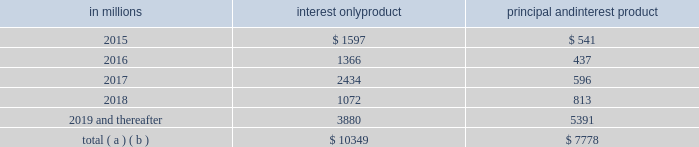On a regular basis our special asset committee closely monitors loans , primarily commercial loans , that are not included in the nonperforming or accruing past due categories and for which we are uncertain about the borrower 2019s ability to comply with existing repayment terms .
These loans totaled $ .2 billion at both december 31 , 2014 and december 31 , 2013 .
Home equity loan portfolio our home equity loan portfolio totaled $ 34.7 billion as of december 31 , 2014 , or 17% ( 17 % ) of the total loan portfolio .
Of that total , $ 20.4 billion , or 59% ( 59 % ) , was outstanding under primarily variable-rate home equity lines of credit and $ 14.3 billion , or 41% ( 41 % ) , consisted of closed-end home equity installment loans .
Approximately 3% ( 3 % ) of the home equity portfolio was on nonperforming status as of december 31 , 2014 .
As of december 31 , 2014 , we are in an originated first lien position for approximately 51% ( 51 % ) of the total portfolio and , where originated as a second lien , we currently hold or service the first lien position for approximately an additional 2% ( 2 % ) of the portfolio .
The remaining 47% ( 47 % ) of the portfolio was secured by second liens where we do not hold the first lien position .
The credit performance of the majority of the home equity portfolio where we are in , hold or service the first lien position , is superior to the portion of the portfolio where we hold the second lien position but do not hold the first lien .
Lien position information is generally based upon original ltv at the time of origination .
However , after origination pnc is not typically notified when a senior lien position that is not held by pnc is satisfied .
Therefore , information about the current lien status of junior lien loans is less readily available in cases where pnc does not also hold the senior lien .
Additionally , pnc is not typically notified when a junior lien position is added after origination of a pnc first lien .
This updated information for both junior and senior liens must be obtained from external sources , and therefore , pnc has contracted with an industry-leading third-party service provider to obtain updated loan , lien and collateral data that is aggregated from public and private sources .
We track borrower performance monthly , including obtaining original ltvs , updated fico scores at least quarterly , updated ltvs semi-annually , and other credit metrics at least quarterly , including the historical performance of any mortgage loans regardless of lien position that we do or do not hold .
This information is used for internal reporting and risk management .
For internal reporting and risk management we also segment the population into pools based on product type ( e.g. , home equity loans , brokered home equity loans , home equity lines of credit , brokered home equity lines of credit ) .
As part of our overall risk analysis and monitoring , we segment the home equity portfolio based upon the delinquency , modification status and bankruptcy status of these loans , as well as the delinquency , modification status and bankruptcy status of any mortgage loan with the same borrower ( regardless of whether it is a first lien senior to our second lien ) .
In establishing our alll for non-impaired loans , we primarily utilize a delinquency roll-rate methodology for pools of loans .
In accordance with accounting principles , under this methodology , we establish our allowance based upon incurred losses , not lifetime expected losses .
The roll-rate methodology estimates transition/roll of loan balances from one delinquency state ( e.g. , 30-59 days past due ) to another delinquency state ( e.g. , 60-89 days past due ) and ultimately to charge-off .
The roll through to charge-off is based on pnc 2019s actual loss experience for each type of pool .
Each of our home equity pools contains both first and second liens .
Our experience has been that the ratio of first to second lien loans has been consistent over time and the charge-off amounts for the pools , used to establish our allowance , include losses on both first and second liens loans .
Generally , our variable-rate home equity lines of credit have either a seven or ten year draw period , followed by a 20-year amortization term .
During the draw period , we have home equity lines of credit where borrowers pay either interest or principal and interest .
We view home equity lines of credit where borrowers are paying principal and interest under the draw period as less risky than those where the borrowers are paying interest only , as these borrowers have a demonstrated ability to make some level of principal and interest payments .
The risk associated with the borrower 2019s ability to satisfy the loan terms upon the draw period ending is considered in establishing our alll .
Based upon outstanding balances at december 31 , 2014 , the table presents the periods when home equity lines of credit draw periods are scheduled to end .
Table 36 : home equity lines of credit 2013 draw period end in millions interest only product principal and interest product .
( a ) includes all home equity lines of credit that mature in 2015 or later , including those with borrowers where we have terminated borrowing privileges .
( b ) includes approximately $ 154 million , $ 48 million , $ 57 million , $ 42 million and $ 564 million of home equity lines of credit with balloon payments , including those where we have terminated borrowing privileges , with draw periods scheduled to end in 2015 , 2016 , 2017 , 2018 and 2019 and thereafter , respectively .
76 the pnc financial services group , inc .
2013 form 10-k .
For total interest only home equity lines of credit , what percentage of the total includes home equity lines of credit with balloon payments , including those where we have terminated borrowing privileges , with draw periods scheduled to end in 2016? 
Computations: (48 / 10349)
Answer: 0.00464. 